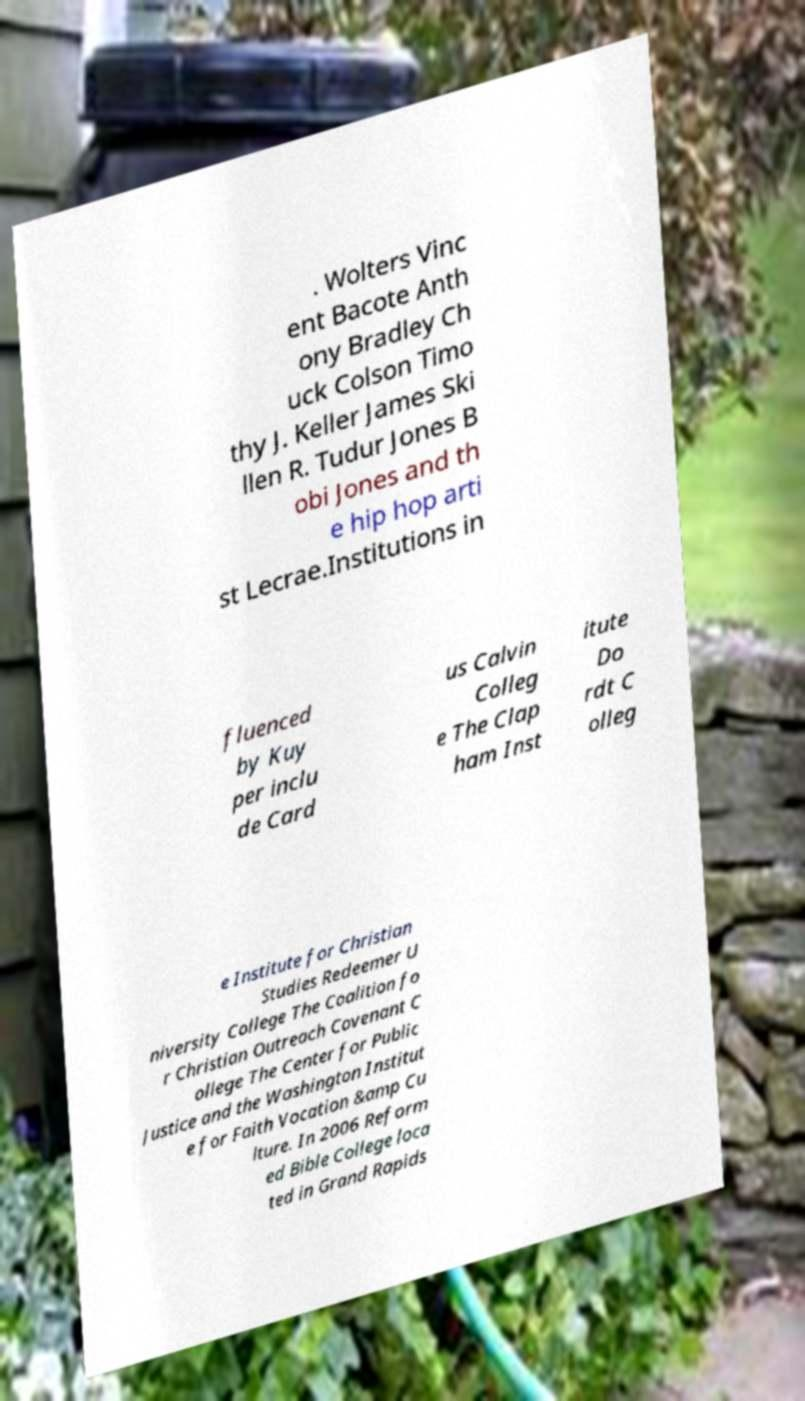Can you accurately transcribe the text from the provided image for me? . Wolters Vinc ent Bacote Anth ony Bradley Ch uck Colson Timo thy J. Keller James Ski llen R. Tudur Jones B obi Jones and th e hip hop arti st Lecrae.Institutions in fluenced by Kuy per inclu de Card us Calvin Colleg e The Clap ham Inst itute Do rdt C olleg e Institute for Christian Studies Redeemer U niversity College The Coalition fo r Christian Outreach Covenant C ollege The Center for Public Justice and the Washington Institut e for Faith Vocation &amp Cu lture. In 2006 Reform ed Bible College loca ted in Grand Rapids 